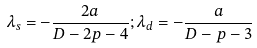Convert formula to latex. <formula><loc_0><loc_0><loc_500><loc_500>\lambda _ { s } = - \frac { 2 a } { D - 2 p - 4 } ; \lambda _ { d } = - \frac { a } { D - p - 3 }</formula> 